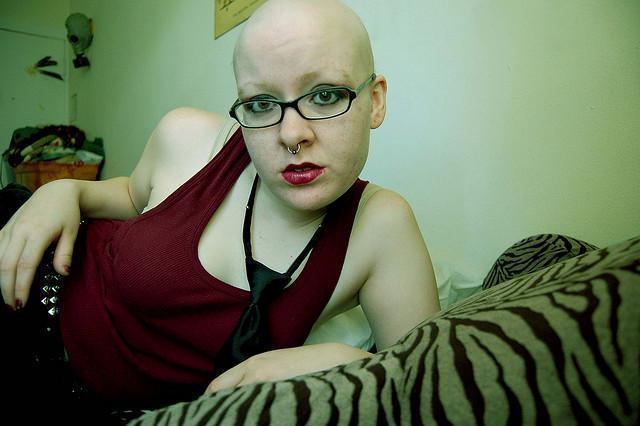What is sh doing?
Choose the correct response and explain in the format: 'Answer: answer
Rationale: rationale.'
Options: Eating, posing, sleeping, resting. Answer: posing.
Rationale: She is laying on one arm with the other arm cocked over her waist. 